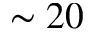<formula> <loc_0><loc_0><loc_500><loc_500>\sim 2 0</formula> 